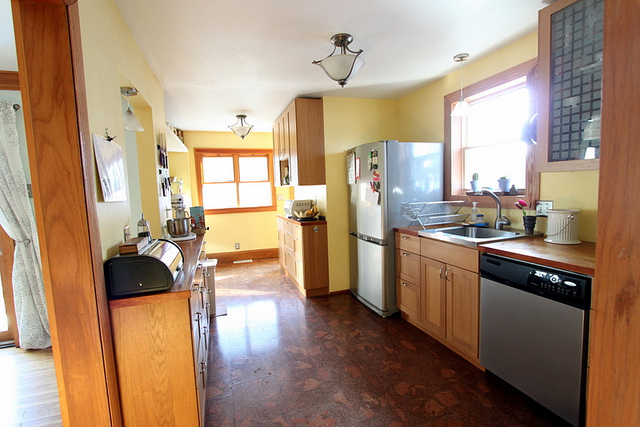Are all the appliances stainless steel? Yes, all the appliances visible in the image, including the refrigerator and dishwasher, feature a stainless steel finish. 